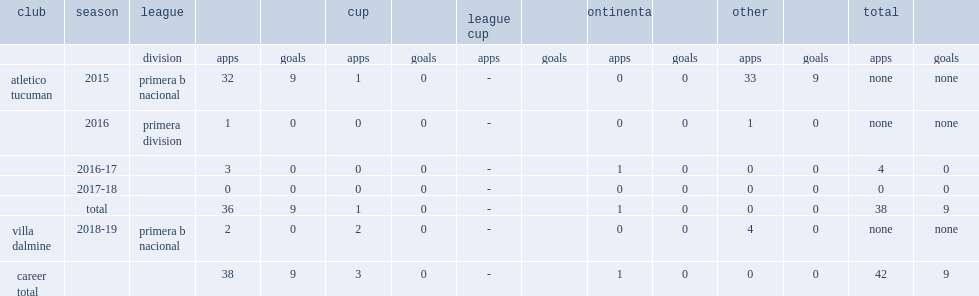Parse the full table. {'header': ['club', 'season', 'league', '', '', 'cup', '', 'league cup', '', 'continental', '', 'other', '', 'total', ''], 'rows': [['', '', 'division', 'apps', 'goals', 'apps', 'goals', 'apps', 'goals', 'apps', 'goals', 'apps', 'goals', 'apps', 'goals'], ['atletico tucuman', '2015', 'primera b nacional', '32', '9', '1', '0', '-', '', '0', '0', '33', '9', 'none', 'none'], ['', '2016', 'primera division', '1', '0', '0', '0', '-', '', '0', '0', '1', '0', 'none', 'none'], ['', '2016-17', '', '3', '0', '0', '0', '-', '', '1', '0', '0', '0', '4', '0'], ['', '2017-18', '', '0', '0', '0', '0', '-', '', '0', '0', '0', '0', '0', '0'], ['', 'total', '', '36', '9', '1', '0', '-', '', '1', '0', '0', '0', '38', '9'], ['villa dalmine', '2018-19', 'primera b nacional', '2', '0', '2', '0', '-', '', '0', '0', '4', '0', 'none', 'none'], ['career total', '', '', '38', '9', '3', '0', '-', '', '1', '0', '0', '0', '42', '9']]} How many appearances did emanuel molina make for atletico tucuman and then moved to the argentine primera division in the 2016 season? 32.0. How many goals did emanuel molina score for atletico tucuman and then moved to the argentine primera division in the 2016 season? 9.0. 